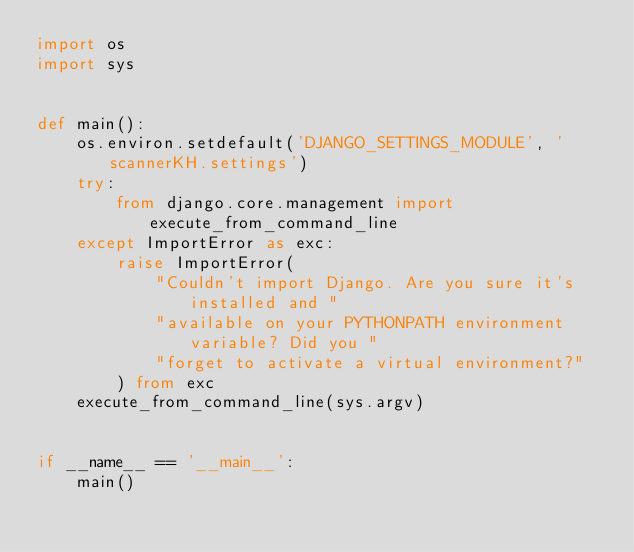<code> <loc_0><loc_0><loc_500><loc_500><_Python_>import os
import sys


def main():
    os.environ.setdefault('DJANGO_SETTINGS_MODULE', 'scannerKH.settings')
    try:
        from django.core.management import execute_from_command_line
    except ImportError as exc:
        raise ImportError(
            "Couldn't import Django. Are you sure it's installed and "
            "available on your PYTHONPATH environment variable? Did you "
            "forget to activate a virtual environment?"
        ) from exc
    execute_from_command_line(sys.argv)


if __name__ == '__main__':
    main()
</code> 